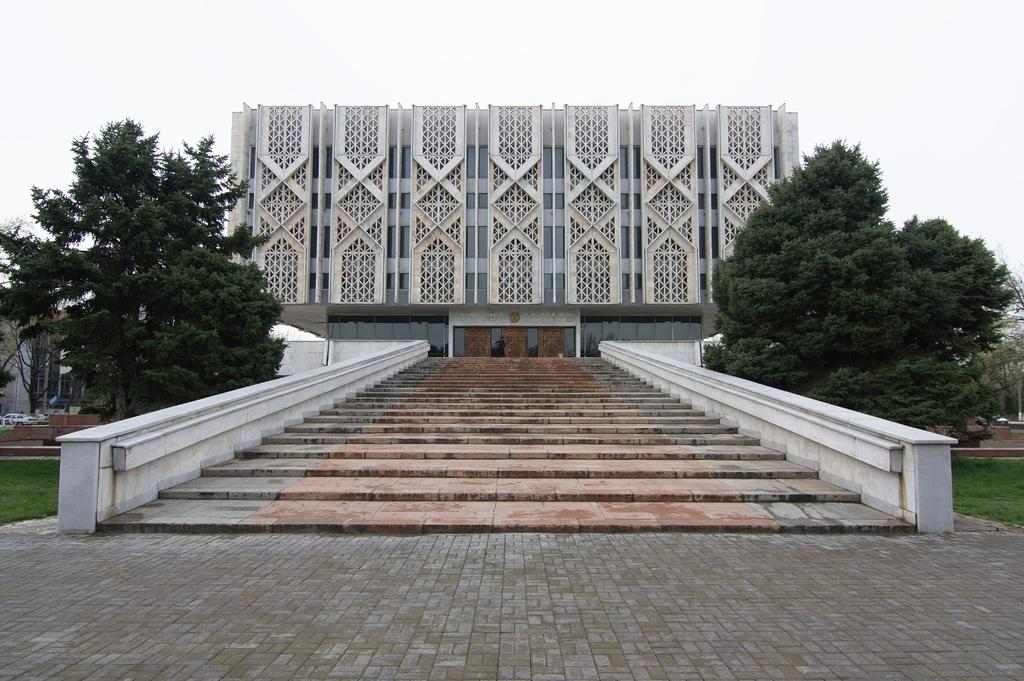What type of structure can be seen in the image? There are stairs in the image. What can be seen in the background of the image? There are trees in the background of the image. What is the color of the trees? The trees are green. What other structure is present in the image? There is a building in the image. What is the color of the building? The building is white. What is the color of the sky in the image? The sky is white in the image. What date is marked on the calendar in the image? There is no calendar present in the image. How does the water flow down the stairs in the image? There is no water present in the image; it only features stairs, trees, a building, and the sky. 